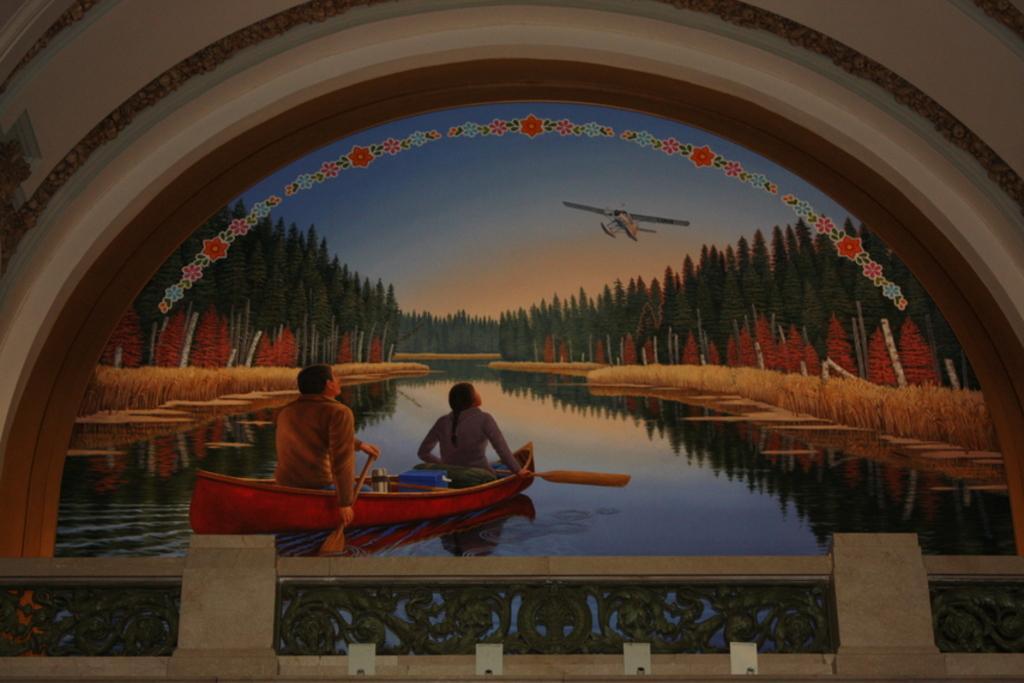Can you describe this image briefly? In the image we can see there is a portrait on the wall. There are people sitting in the boat and the boat is docked in the river. There are trees and there is an aircraft flying in the sky. There are iron railings on the wall. 